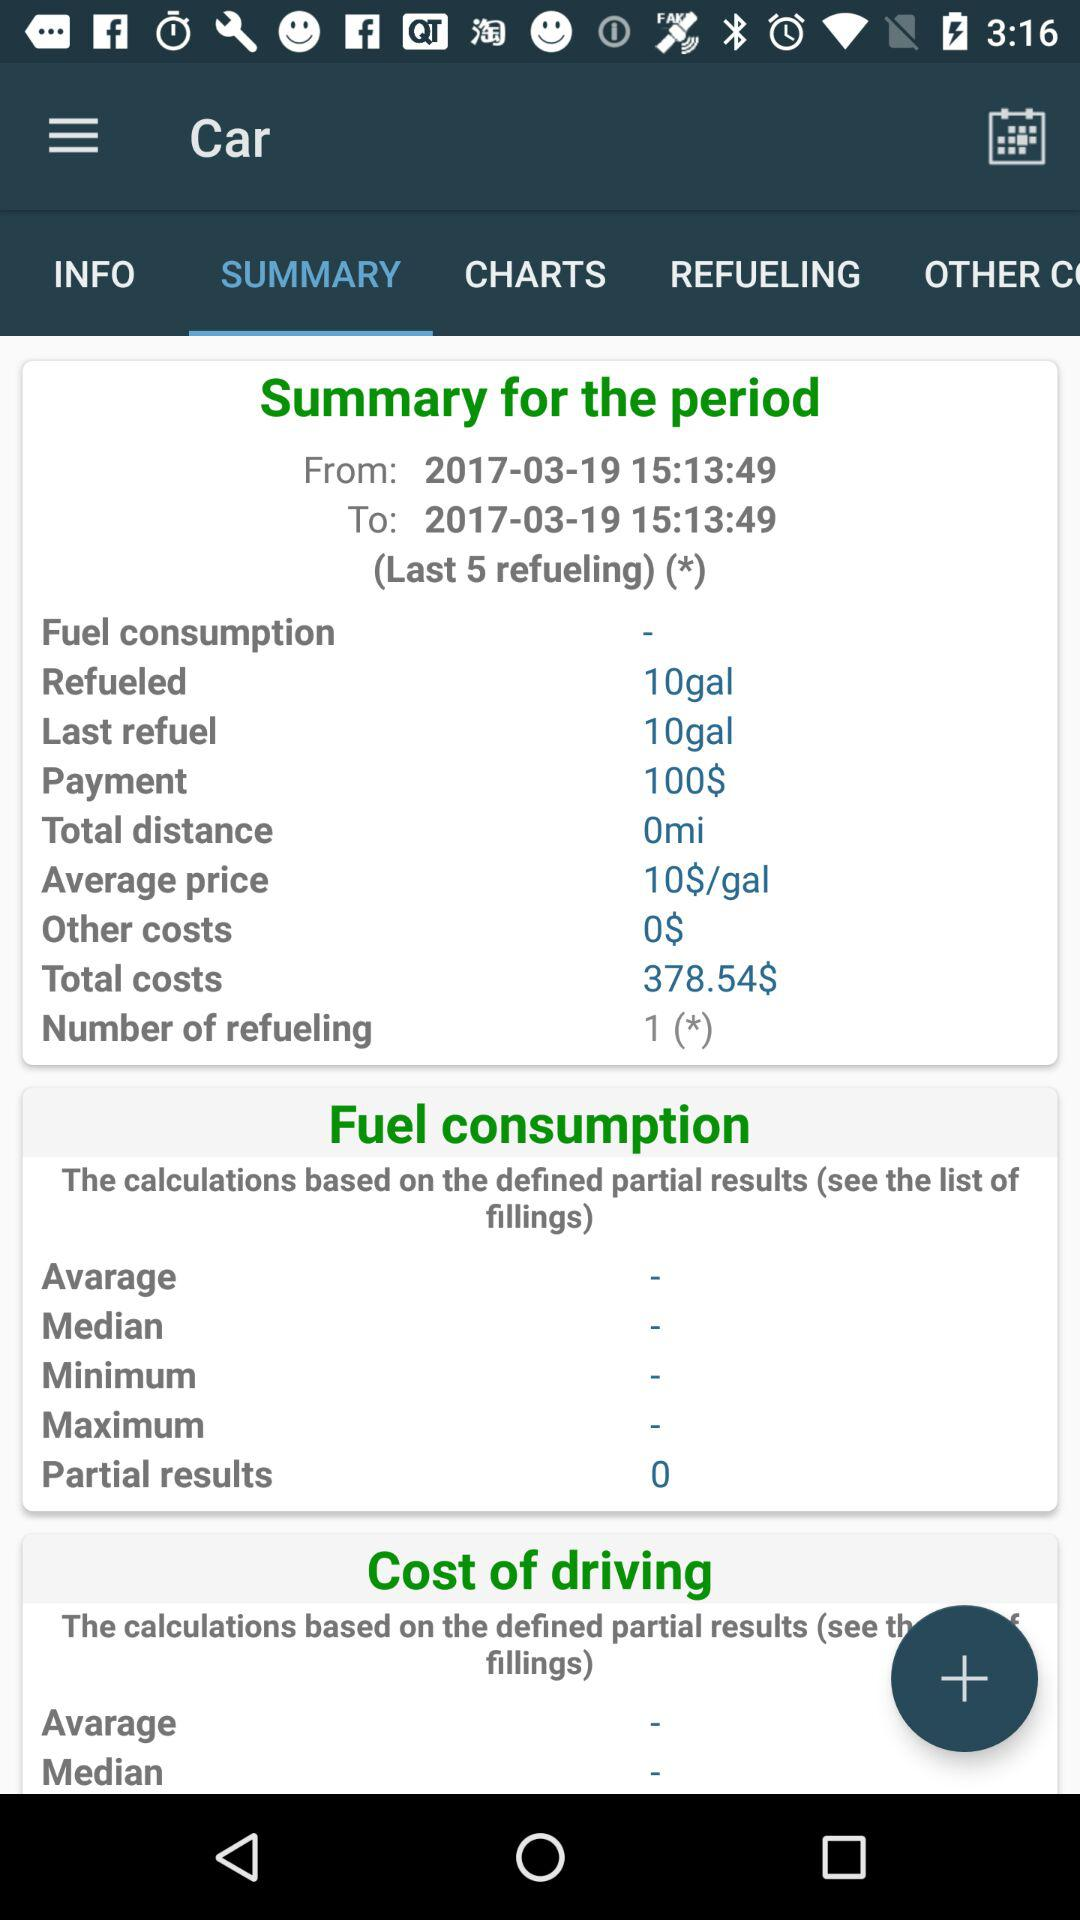How much money was spent on fuel?
Answer the question using a single word or phrase. 378.54$ 